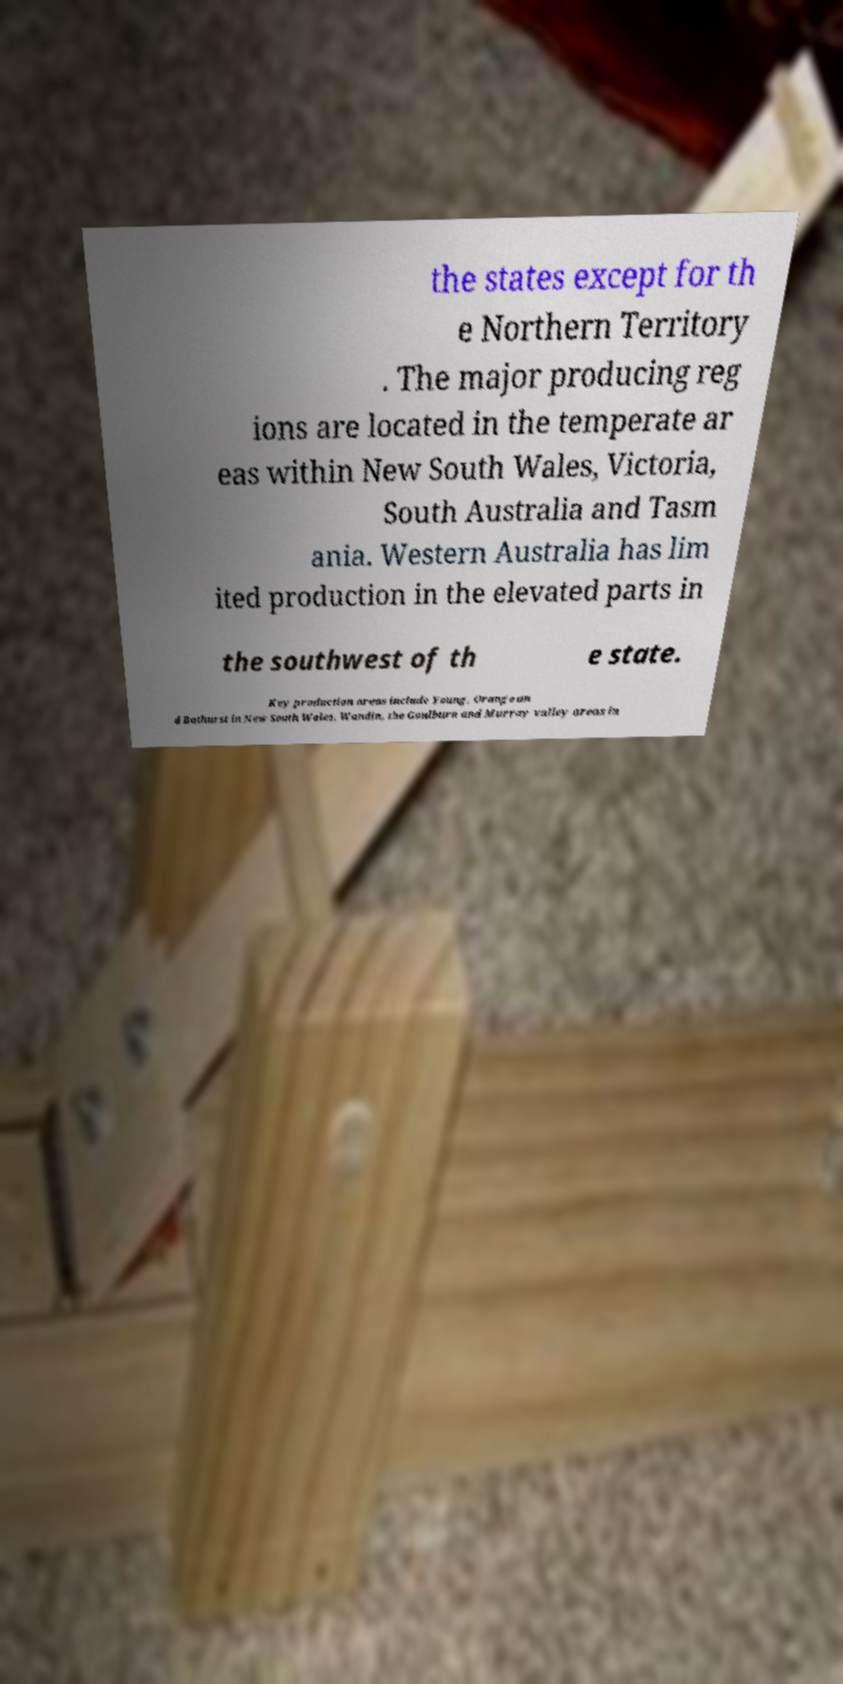For documentation purposes, I need the text within this image transcribed. Could you provide that? the states except for th e Northern Territory . The major producing reg ions are located in the temperate ar eas within New South Wales, Victoria, South Australia and Tasm ania. Western Australia has lim ited production in the elevated parts in the southwest of th e state. Key production areas include Young, Orange an d Bathurst in New South Wales, Wandin, the Goulburn and Murray valley areas in 